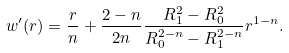Convert formula to latex. <formula><loc_0><loc_0><loc_500><loc_500>w ^ { \prime } ( r ) = \frac { r } { n } + \frac { 2 - n } { 2 n } \frac { R _ { 1 } ^ { 2 } - R _ { 0 } ^ { 2 } } { R _ { 0 } ^ { 2 - n } - R _ { 1 } ^ { 2 - n } } r ^ { 1 - n } .</formula> 